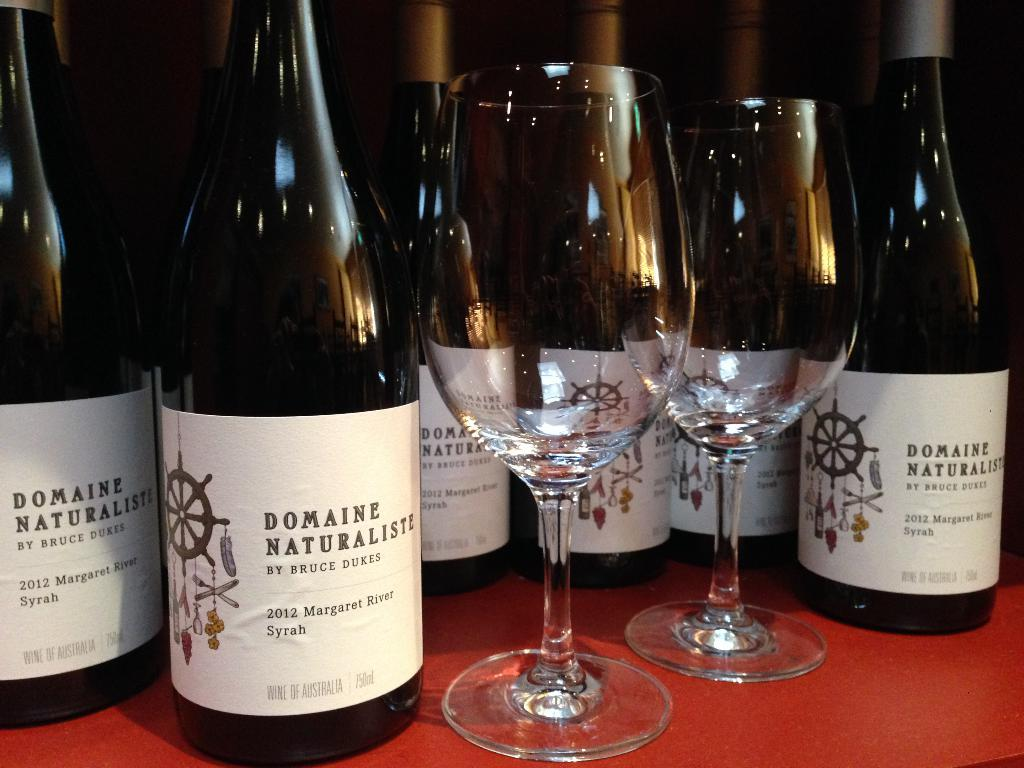<image>
Summarize the visual content of the image. several bottles of Domaine Naturaliste and glasses on display 